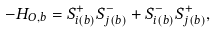Convert formula to latex. <formula><loc_0><loc_0><loc_500><loc_500>- H _ { O , b } = S _ { i ( b ) } ^ { + } S _ { j ( b ) } ^ { - } + S _ { i ( b ) } ^ { - } S _ { j ( b ) } ^ { + } ,</formula> 